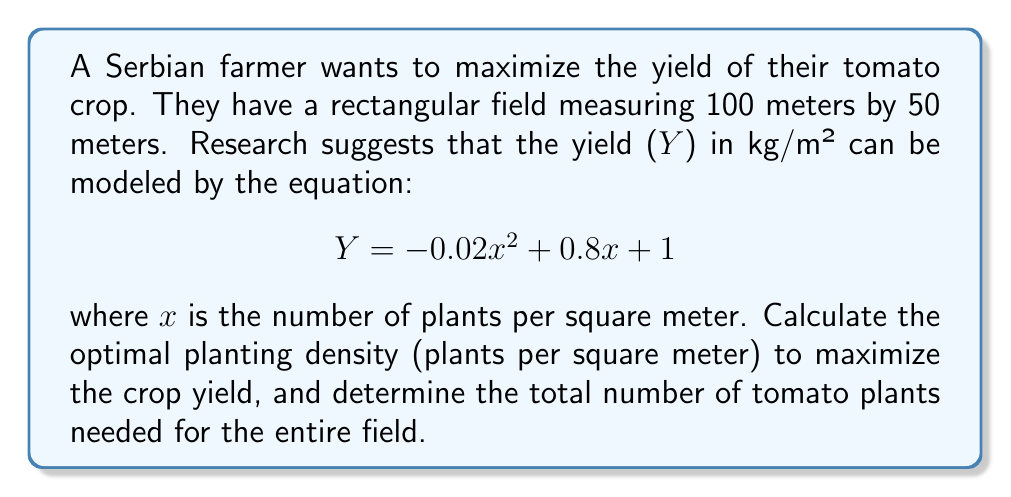Help me with this question. 1. To find the optimal planting density, we need to find the maximum of the yield function Y(x).

2. The maximum of a quadratic function occurs at the vertex of the parabola. For a quadratic function in the form $ax^2 + bx + c$, the x-coordinate of the vertex is given by $x = -\frac{b}{2a}$.

3. In our case, $a = -0.02$, $b = 0.8$, and $c = 1$. Let's calculate the optimal x:

   $$ x = -\frac{0.8}{2(-0.02)} = -\frac{0.8}{-0.04} = 20 $$

4. Therefore, the optimal planting density is 20 plants per square meter.

5. To calculate the total number of plants needed, we first need to find the area of the field:

   Area = length × width = 100 m × 50 m = 5000 m²

6. The total number of plants is the product of the optimal density and the area:

   Total plants = optimal density × area = 20 plants/m² × 5000 m² = 100,000 plants
Answer: 20 plants/m²; 100,000 plants 